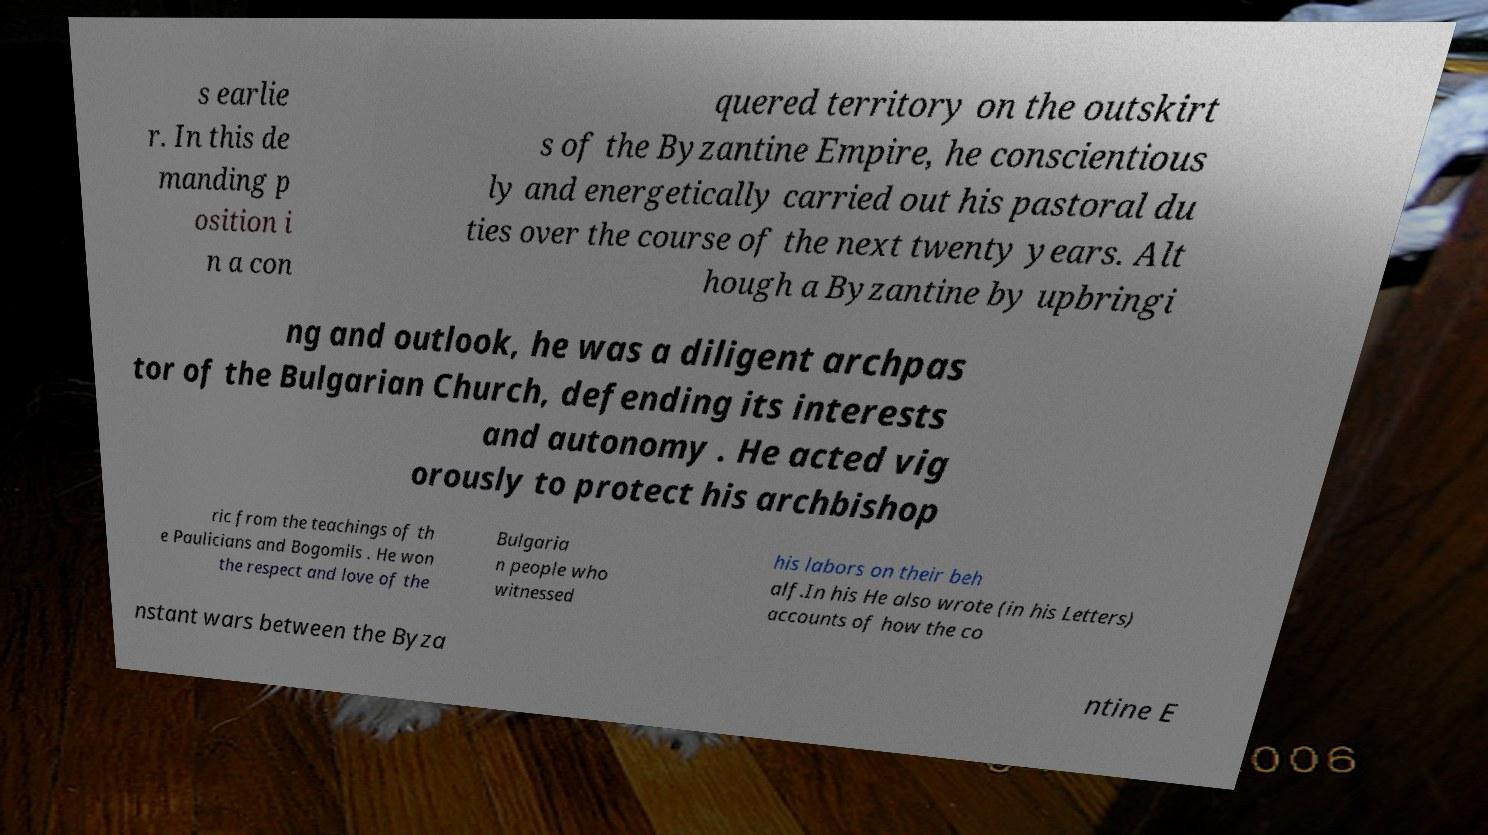What messages or text are displayed in this image? I need them in a readable, typed format. s earlie r. In this de manding p osition i n a con quered territory on the outskirt s of the Byzantine Empire, he conscientious ly and energetically carried out his pastoral du ties over the course of the next twenty years. Alt hough a Byzantine by upbringi ng and outlook, he was a diligent archpas tor of the Bulgarian Church, defending its interests and autonomy . He acted vig orously to protect his archbishop ric from the teachings of th e Paulicians and Bogomils . He won the respect and love of the Bulgaria n people who witnessed his labors on their beh alf.In his He also wrote (in his Letters) accounts of how the co nstant wars between the Byza ntine E 